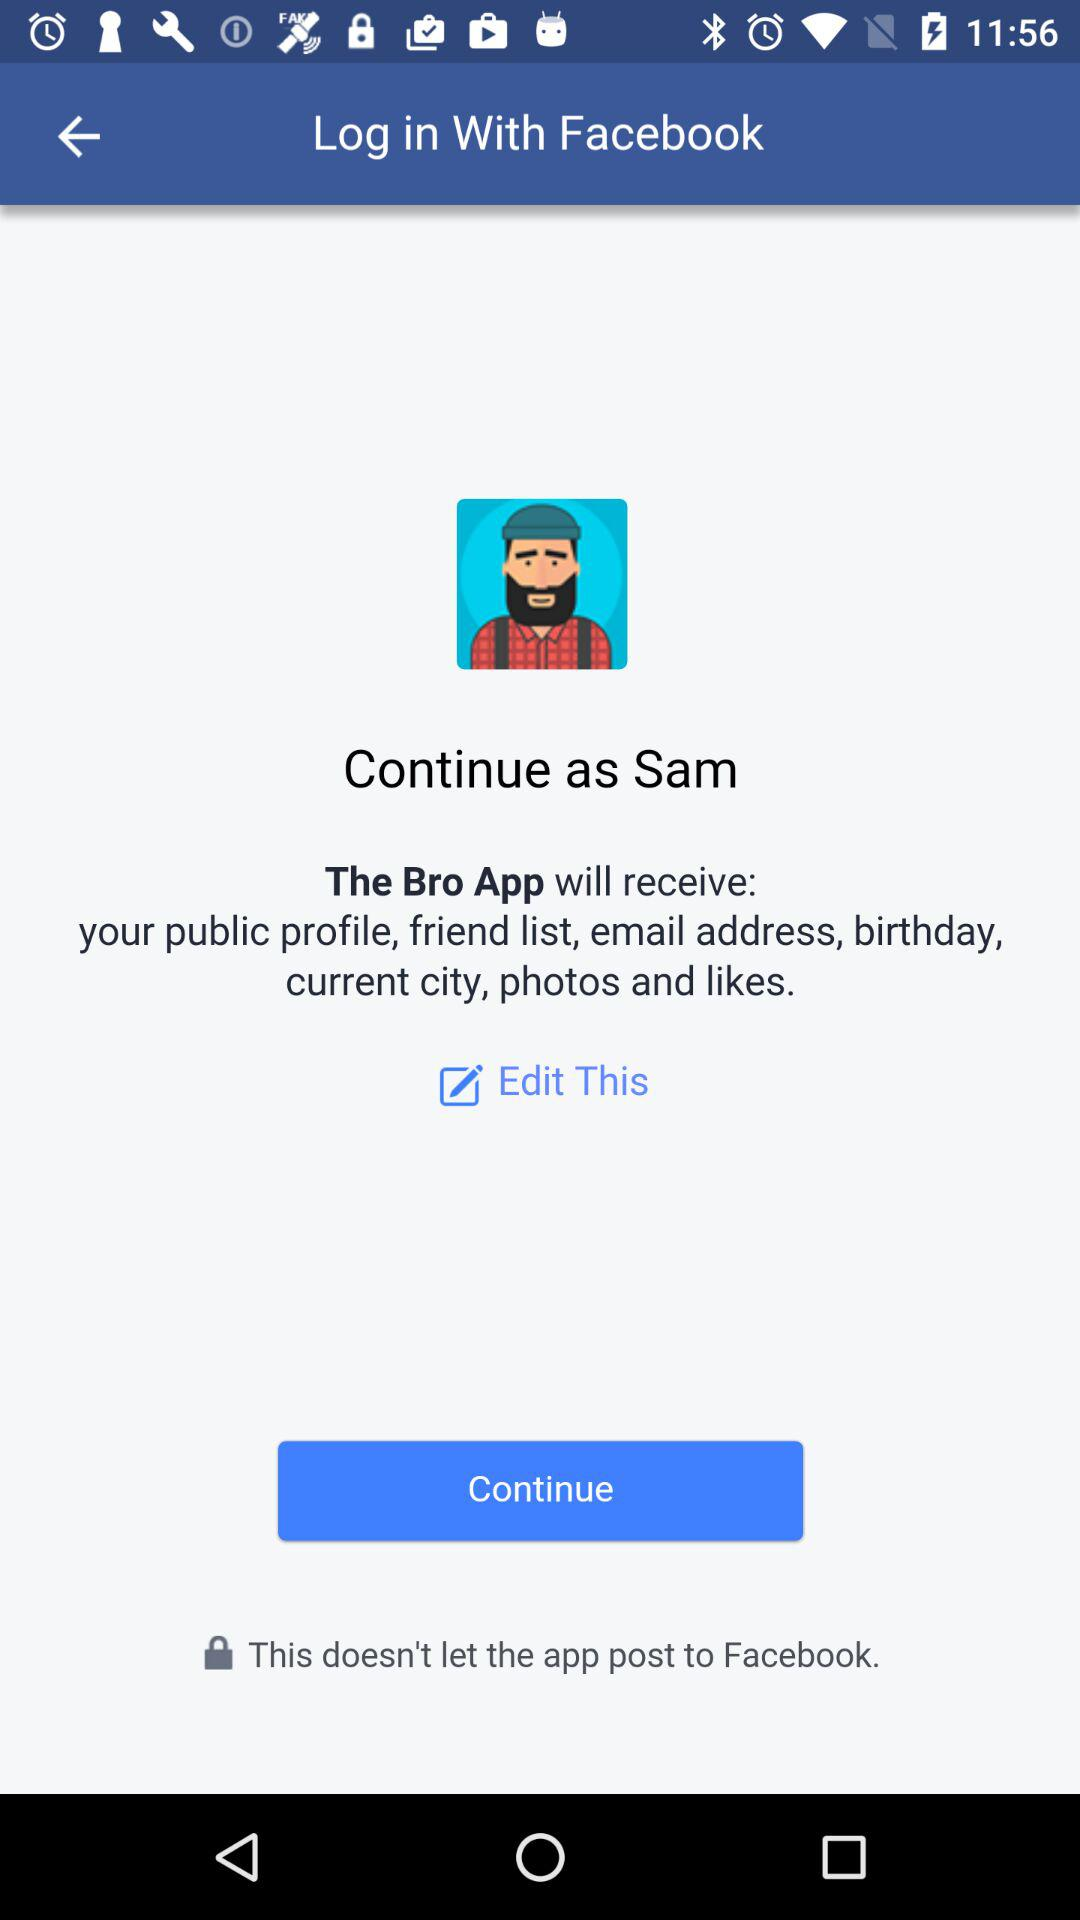What is the name of the user? The name of the user is Sam. 